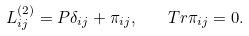<formula> <loc_0><loc_0><loc_500><loc_500>L ^ { ( 2 ) } _ { i j } = P \delta _ { i j } + \pi _ { i j } , \quad T r \pi _ { i j } = 0 .</formula> 